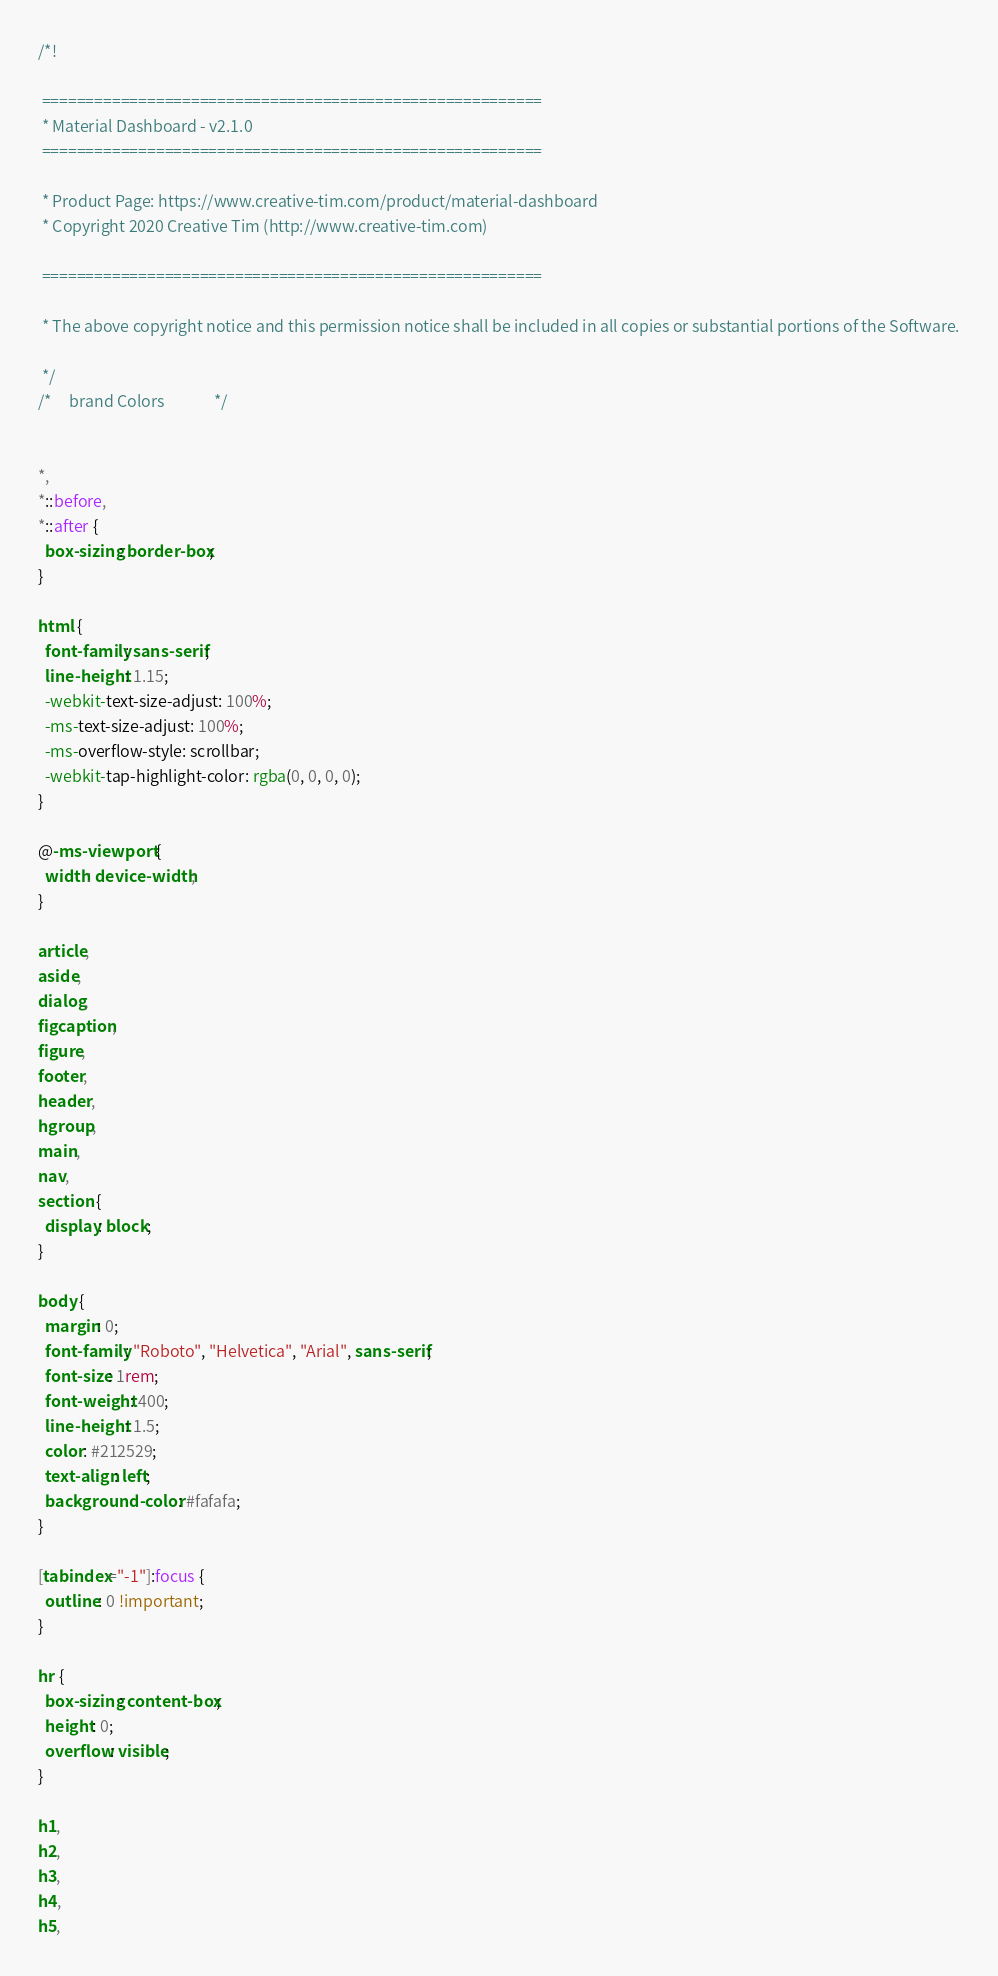Convert code to text. <code><loc_0><loc_0><loc_500><loc_500><_CSS_>/*!

 =========================================================
 * Material Dashboard - v2.1.0
 =========================================================

 * Product Page: https://www.creative-tim.com/product/material-dashboard
 * Copyright 2020 Creative Tim (http://www.creative-tim.com)

 =========================================================

 * The above copyright notice and this permission notice shall be included in all copies or substantial portions of the Software.

 */
/*     brand Colors              */


*,
*::before,
*::after {
  box-sizing: border-box;
}

html {
  font-family: sans-serif;
  line-height: 1.15;
  -webkit-text-size-adjust: 100%;
  -ms-text-size-adjust: 100%;
  -ms-overflow-style: scrollbar;
  -webkit-tap-highlight-color: rgba(0, 0, 0, 0);
}

@-ms-viewport {
  width: device-width;
}

article,
aside,
dialog,
figcaption,
figure,
footer,
header,
hgroup,
main,
nav,
section {
  display: block;
}

body {
  margin: 0;
  font-family: "Roboto", "Helvetica", "Arial", sans-serif;
  font-size: 1rem;
  font-weight: 400;
  line-height: 1.5;
  color: #212529;
  text-align: left;
  background-color: #fafafa;
}

[tabindex="-1"]:focus {
  outline: 0 !important;
}

hr {
  box-sizing: content-box;
  height: 0;
  overflow: visible;
}

h1,
h2,
h3,
h4,
h5,</code> 